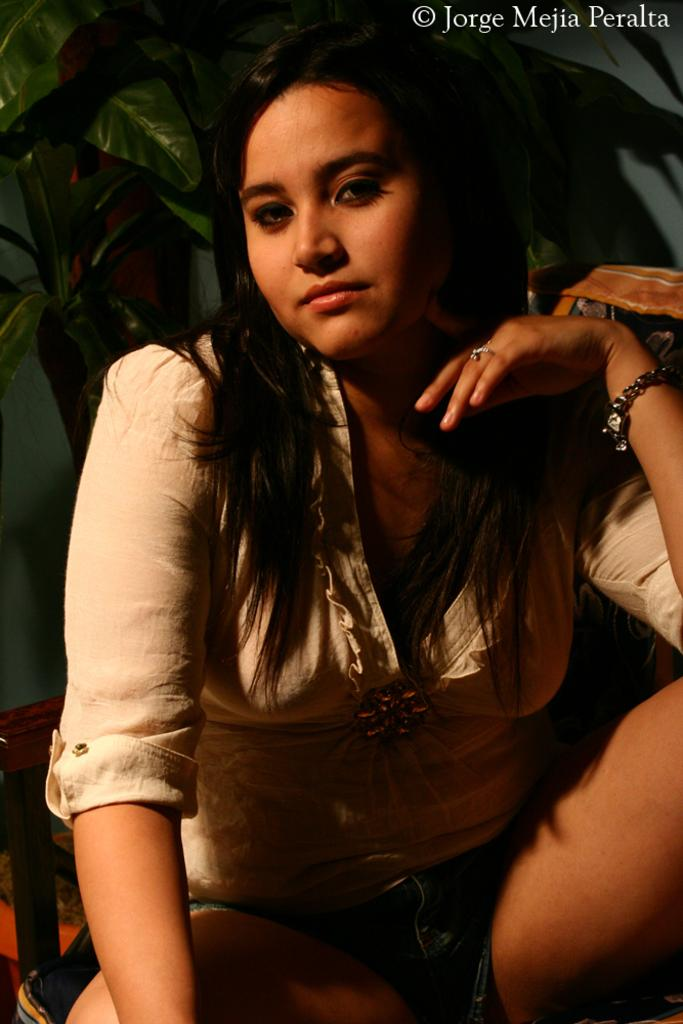Who is present in the image? There is a woman in the image. What type of vegetation can be seen in the image? There are leaves in the image. What else can be seen in the image besides the woman and leaves? There are some objects in the image. Can you describe any additional features of the image? There is a watermark in the top right corner of the image. What type of disease is affecting the leaves in the image? There is no indication of any disease affecting the leaves in the image; they appear to be healthy. 